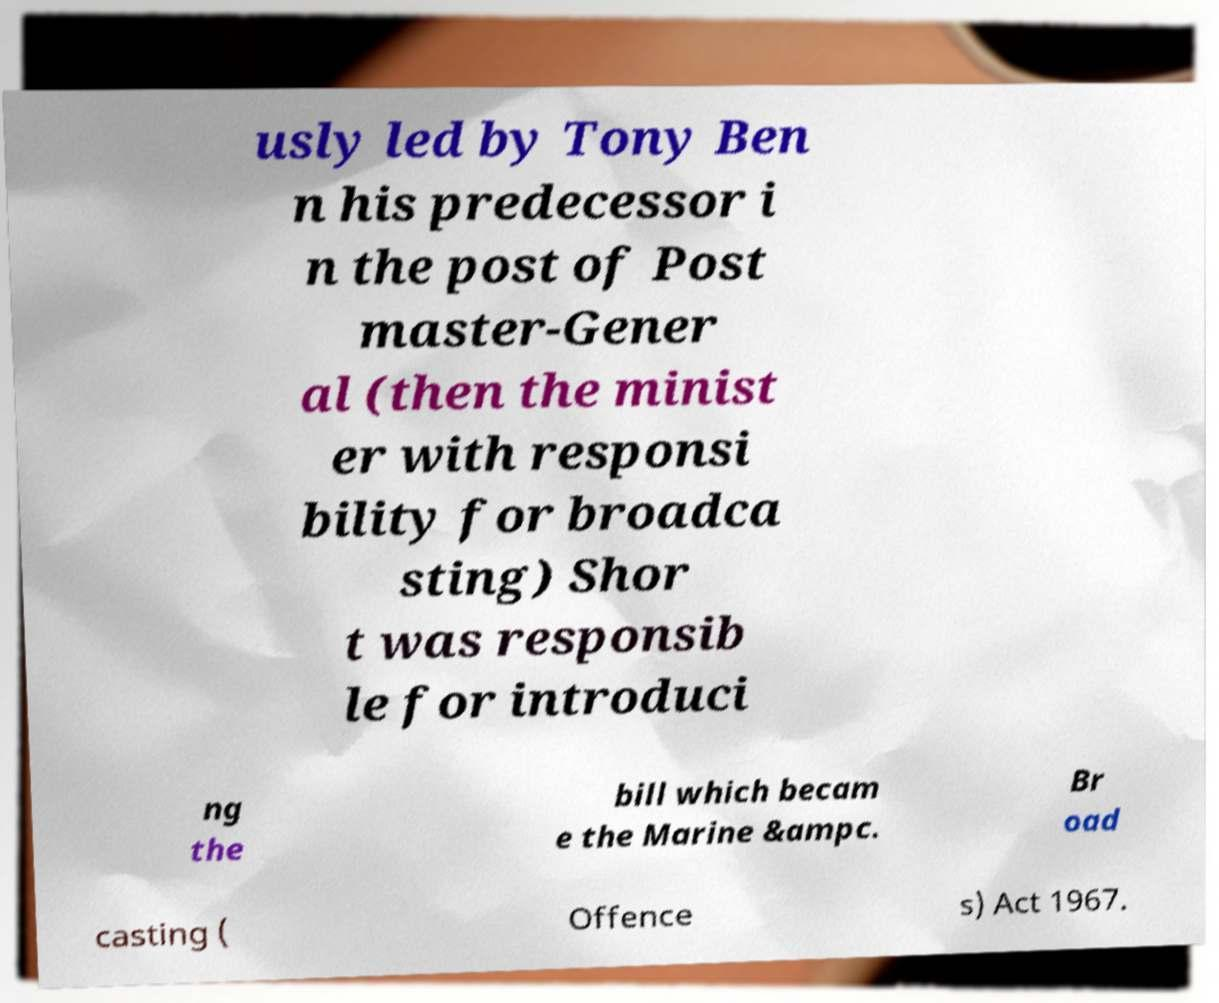What messages or text are displayed in this image? I need them in a readable, typed format. usly led by Tony Ben n his predecessor i n the post of Post master-Gener al (then the minist er with responsi bility for broadca sting) Shor t was responsib le for introduci ng the bill which becam e the Marine &ampc. Br oad casting ( Offence s) Act 1967. 